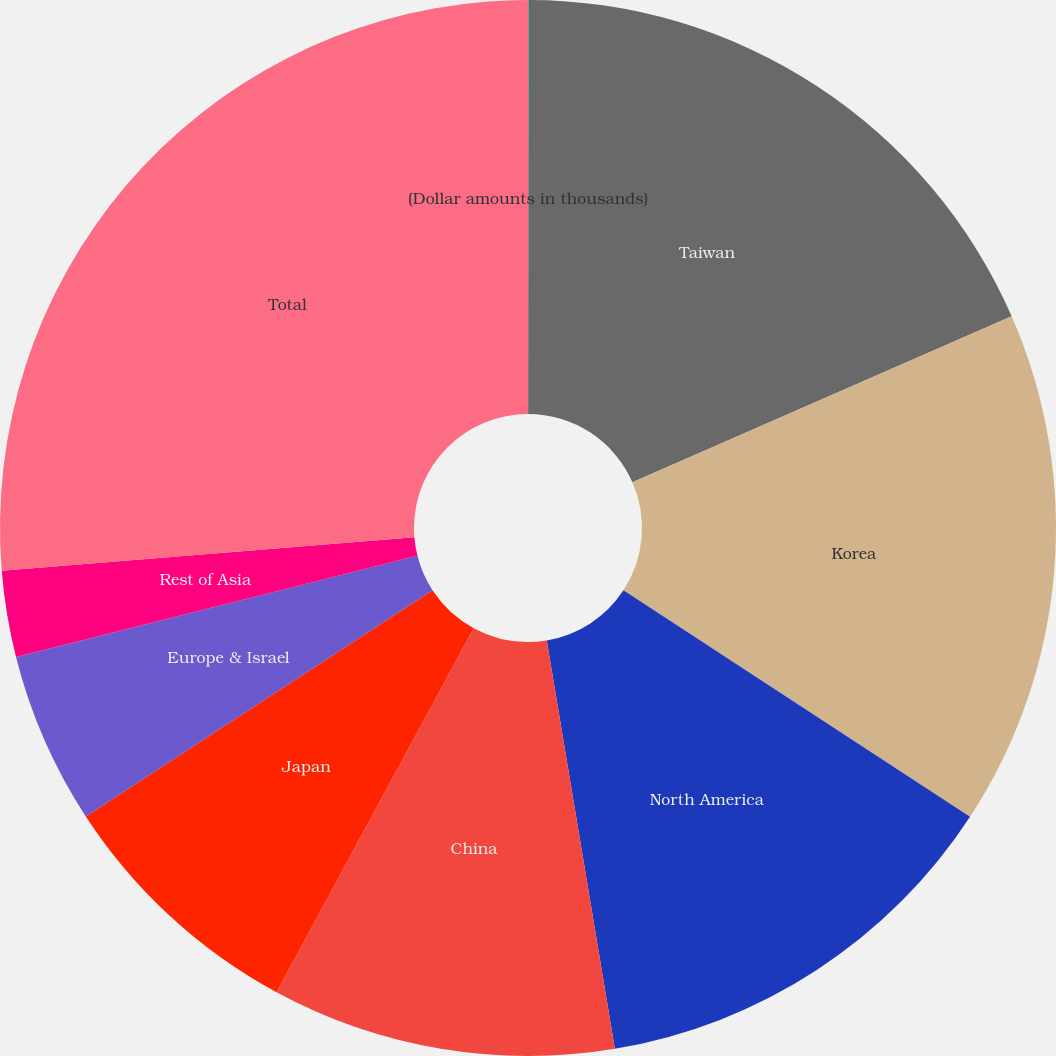<chart> <loc_0><loc_0><loc_500><loc_500><pie_chart><fcel>(Dollar amounts in thousands)<fcel>Taiwan<fcel>Korea<fcel>North America<fcel>China<fcel>Japan<fcel>Europe & Israel<fcel>Rest of Asia<fcel>Total<nl><fcel>0.02%<fcel>18.41%<fcel>15.78%<fcel>13.16%<fcel>10.53%<fcel>7.9%<fcel>5.27%<fcel>2.64%<fcel>26.29%<nl></chart> 